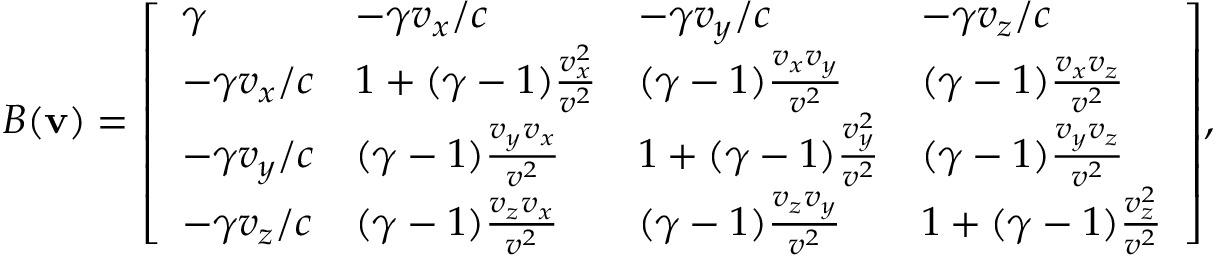<formula> <loc_0><loc_0><loc_500><loc_500>B ( v ) = { \left [ \begin{array} { l l l l } { \gamma } & { - \gamma v _ { x } / c } & { - \gamma v _ { y } / c } & { - \gamma v _ { z } / c } \\ { - \gamma v _ { x } / c } & { 1 + ( \gamma - 1 ) { \frac { v _ { x } ^ { 2 } } { v ^ { 2 } } } } & { ( \gamma - 1 ) { \frac { v _ { x } v _ { y } } { v ^ { 2 } } } } & { ( \gamma - 1 ) { \frac { v _ { x } v _ { z } } { v ^ { 2 } } } } \\ { - \gamma v _ { y } / c } & { ( \gamma - 1 ) { \frac { v _ { y } v _ { x } } { v ^ { 2 } } } } & { 1 + ( \gamma - 1 ) { \frac { v _ { y } ^ { 2 } } { v ^ { 2 } } } } & { ( \gamma - 1 ) { \frac { v _ { y } v _ { z } } { v ^ { 2 } } } } \\ { - \gamma v _ { z } / c } & { ( \gamma - 1 ) { \frac { v _ { z } v _ { x } } { v ^ { 2 } } } } & { ( \gamma - 1 ) { \frac { v _ { z } v _ { y } } { v ^ { 2 } } } } & { 1 + ( \gamma - 1 ) { \frac { v _ { z } ^ { 2 } } { v ^ { 2 } } } } \end{array} \right ] } ,</formula> 